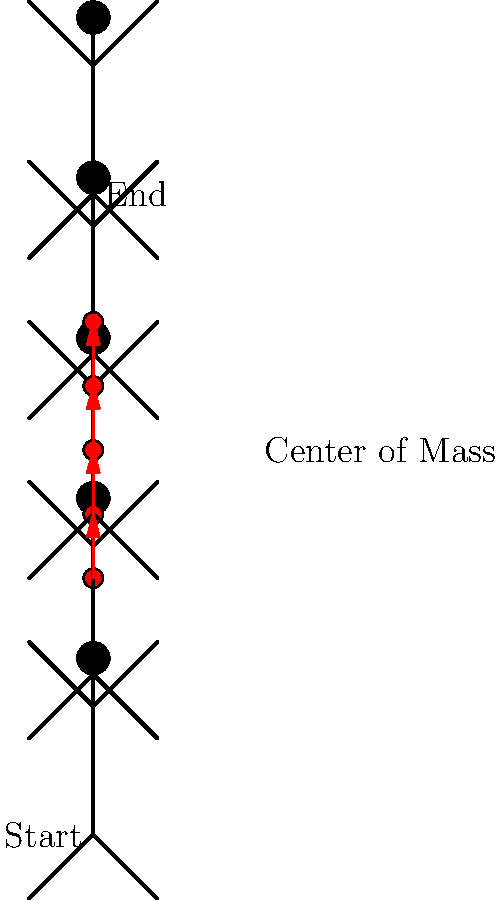Based on the stick figure representation of a vertical jump, what can be inferred about the displacement of the center of mass throughout the movement? Provide a quantitative estimate of the total vertical displacement. To analyze the displacement of the center of mass during the vertical jump, we'll follow these steps:

1. Observe the initial and final positions of the center of mass (red dots).
2. Count the number of intervals between the center of mass positions.
3. Estimate the vertical distance between each interval.
4. Calculate the total displacement.

Step 1: The center of mass starts at the lowest point and ends at the highest point.

Step 2: There are 4 intervals between the 5 center of mass positions.

Step 3: Estimating the vertical distance:
- The total height of the figure is approximately 200 units.
- The center of mass moves through about 40% of this height.
- 40% of 200 units is 80 units.
- With 4 intervals, each interval is approximately 20 units.

Step 4: Total displacement calculation:
$$ \text{Total Displacement} = \text{Number of intervals} \times \text{Distance per interval} $$
$$ \text{Total Displacement} = 4 \times 20 \text{ units} = 80 \text{ units} $$

Therefore, the center of mass displaces vertically by approximately 80 units during the jump.
Answer: The center of mass displaces vertically by approximately 80 units. 